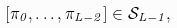<formula> <loc_0><loc_0><loc_500><loc_500>[ \pi _ { 0 } , \dots , \pi _ { L - 2 } ] \in \mathcal { S } _ { L - 1 } ,</formula> 